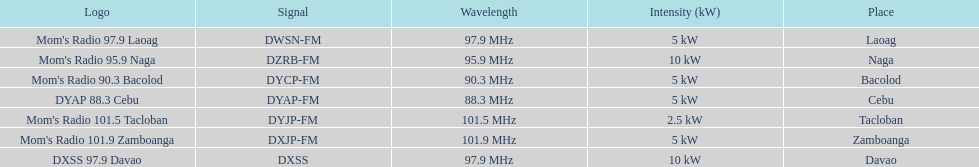How many times is the frequency greater than 95? 5. 